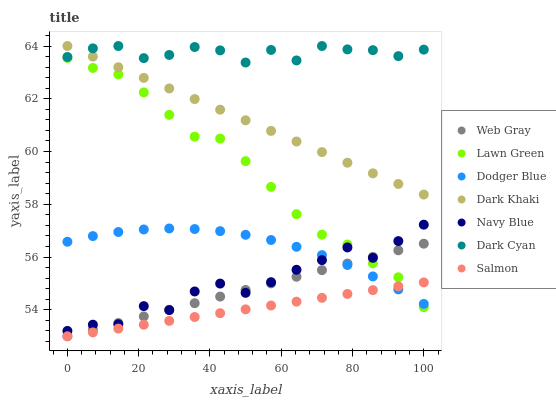Does Salmon have the minimum area under the curve?
Answer yes or no. Yes. Does Dark Cyan have the maximum area under the curve?
Answer yes or no. Yes. Does Web Gray have the minimum area under the curve?
Answer yes or no. No. Does Web Gray have the maximum area under the curve?
Answer yes or no. No. Is Salmon the smoothest?
Answer yes or no. Yes. Is Navy Blue the roughest?
Answer yes or no. Yes. Is Web Gray the smoothest?
Answer yes or no. No. Is Web Gray the roughest?
Answer yes or no. No. Does Web Gray have the lowest value?
Answer yes or no. Yes. Does Navy Blue have the lowest value?
Answer yes or no. No. Does Dark Cyan have the highest value?
Answer yes or no. Yes. Does Web Gray have the highest value?
Answer yes or no. No. Is Dodger Blue less than Dark Cyan?
Answer yes or no. Yes. Is Dark Khaki greater than Navy Blue?
Answer yes or no. Yes. Does Salmon intersect Lawn Green?
Answer yes or no. Yes. Is Salmon less than Lawn Green?
Answer yes or no. No. Is Salmon greater than Lawn Green?
Answer yes or no. No. Does Dodger Blue intersect Dark Cyan?
Answer yes or no. No. 